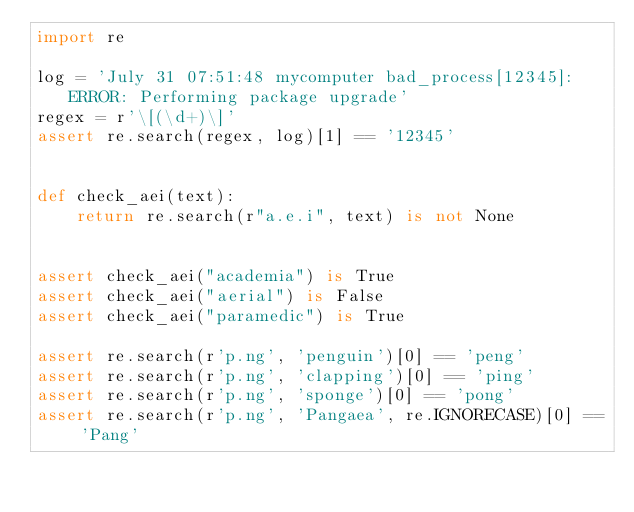<code> <loc_0><loc_0><loc_500><loc_500><_Python_>import re

log = 'July 31 07:51:48 mycomputer bad_process[12345]: ERROR: Performing package upgrade'
regex = r'\[(\d+)\]'
assert re.search(regex, log)[1] == '12345'


def check_aei(text):
    return re.search(r"a.e.i", text) is not None


assert check_aei("academia") is True
assert check_aei("aerial") is False
assert check_aei("paramedic") is True

assert re.search(r'p.ng', 'penguin')[0] == 'peng'
assert re.search(r'p.ng', 'clapping')[0] == 'ping'
assert re.search(r'p.ng', 'sponge')[0] == 'pong'
assert re.search(r'p.ng', 'Pangaea', re.IGNORECASE)[0] == 'Pang'
</code> 